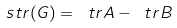<formula> <loc_0><loc_0><loc_500><loc_500>\ s t r ( G ) = \ t r A - \ t r B</formula> 